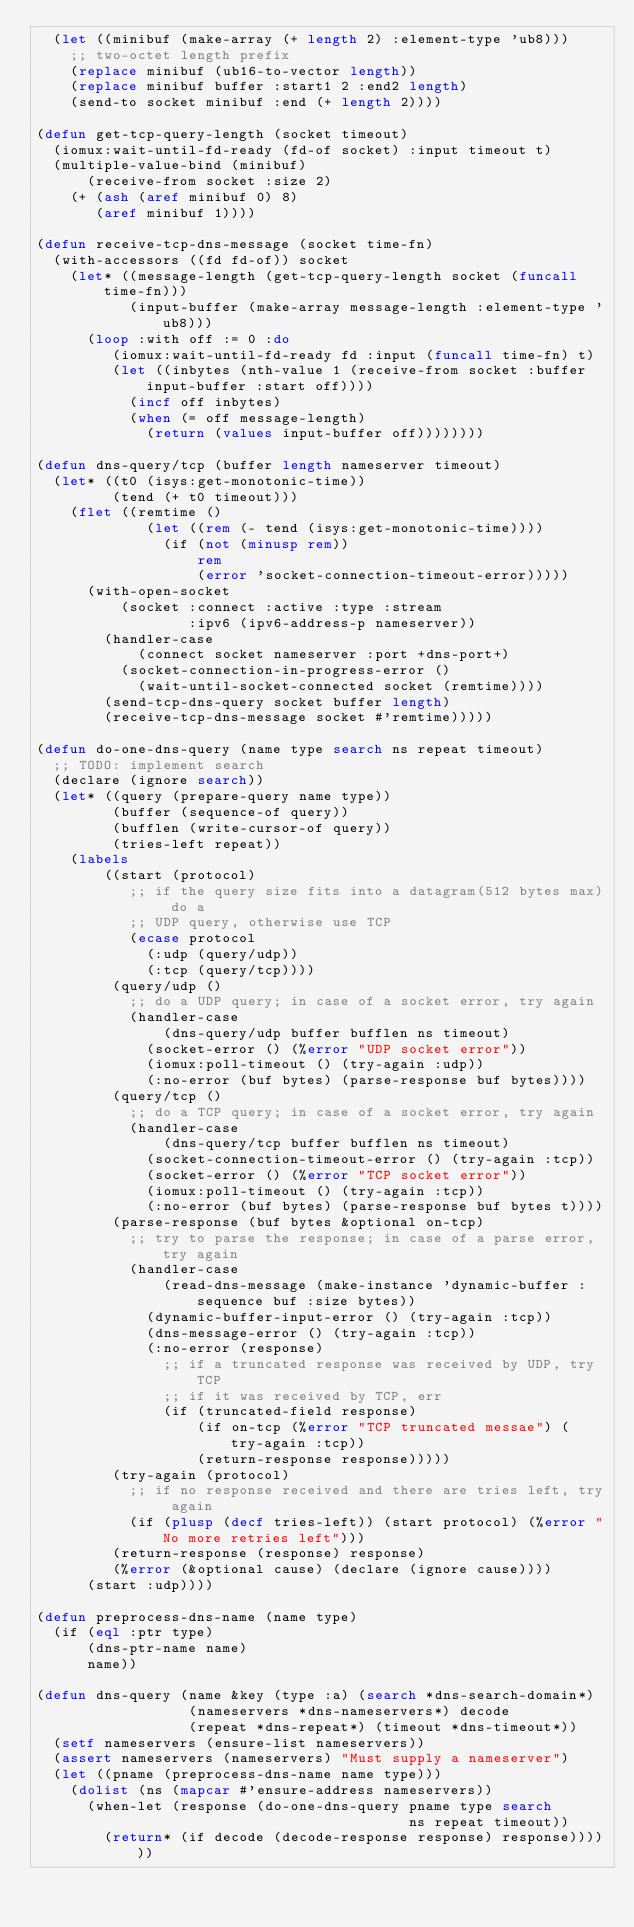<code> <loc_0><loc_0><loc_500><loc_500><_Lisp_>  (let ((minibuf (make-array (+ length 2) :element-type 'ub8)))
    ;; two-octet length prefix
    (replace minibuf (ub16-to-vector length))
    (replace minibuf buffer :start1 2 :end2 length)
    (send-to socket minibuf :end (+ length 2))))

(defun get-tcp-query-length (socket timeout)
  (iomux:wait-until-fd-ready (fd-of socket) :input timeout t)
  (multiple-value-bind (minibuf)
      (receive-from socket :size 2)
    (+ (ash (aref minibuf 0) 8)
       (aref minibuf 1))))

(defun receive-tcp-dns-message (socket time-fn)
  (with-accessors ((fd fd-of)) socket
    (let* ((message-length (get-tcp-query-length socket (funcall time-fn)))
           (input-buffer (make-array message-length :element-type 'ub8)))
      (loop :with off := 0 :do
         (iomux:wait-until-fd-ready fd :input (funcall time-fn) t)
         (let ((inbytes (nth-value 1 (receive-from socket :buffer input-buffer :start off))))
           (incf off inbytes)
           (when (= off message-length)
             (return (values input-buffer off))))))))

(defun dns-query/tcp (buffer length nameserver timeout)
  (let* ((t0 (isys:get-monotonic-time))
         (tend (+ t0 timeout)))
    (flet ((remtime ()
             (let ((rem (- tend (isys:get-monotonic-time))))
               (if (not (minusp rem))
                   rem
                   (error 'socket-connection-timeout-error)))))
      (with-open-socket
          (socket :connect :active :type :stream
                  :ipv6 (ipv6-address-p nameserver))
        (handler-case
            (connect socket nameserver :port +dns-port+)
          (socket-connection-in-progress-error ()
            (wait-until-socket-connected socket (remtime))))
        (send-tcp-dns-query socket buffer length)
        (receive-tcp-dns-message socket #'remtime)))))

(defun do-one-dns-query (name type search ns repeat timeout)
  ;; TODO: implement search
  (declare (ignore search))
  (let* ((query (prepare-query name type))
         (buffer (sequence-of query))
         (bufflen (write-cursor-of query))
         (tries-left repeat))
    (labels
        ((start (protocol)
           ;; if the query size fits into a datagram(512 bytes max) do a
           ;; UDP query, otherwise use TCP
           (ecase protocol
             (:udp (query/udp))
             (:tcp (query/tcp))))
         (query/udp ()
           ;; do a UDP query; in case of a socket error, try again
           (handler-case
               (dns-query/udp buffer bufflen ns timeout)
             (socket-error () (%error "UDP socket error"))
             (iomux:poll-timeout () (try-again :udp))
             (:no-error (buf bytes) (parse-response buf bytes))))
         (query/tcp ()
           ;; do a TCP query; in case of a socket error, try again
           (handler-case
               (dns-query/tcp buffer bufflen ns timeout)
             (socket-connection-timeout-error () (try-again :tcp))
             (socket-error () (%error "TCP socket error"))
             (iomux:poll-timeout () (try-again :tcp))
             (:no-error (buf bytes) (parse-response buf bytes t))))
         (parse-response (buf bytes &optional on-tcp)
           ;; try to parse the response; in case of a parse error, try again
           (handler-case
               (read-dns-message (make-instance 'dynamic-buffer :sequence buf :size bytes))
             (dynamic-buffer-input-error () (try-again :tcp))
             (dns-message-error () (try-again :tcp))
             (:no-error (response)
               ;; if a truncated response was received by UDP, try TCP
               ;; if it was received by TCP, err
               (if (truncated-field response)
                   (if on-tcp (%error "TCP truncated messae") (try-again :tcp))
                   (return-response response)))))
         (try-again (protocol)
           ;; if no response received and there are tries left, try again
           (if (plusp (decf tries-left)) (start protocol) (%error "No more retries left")))
         (return-response (response) response)
         (%error (&optional cause) (declare (ignore cause))))
      (start :udp))))

(defun preprocess-dns-name (name type)
  (if (eql :ptr type)
      (dns-ptr-name name)
      name))

(defun dns-query (name &key (type :a) (search *dns-search-domain*)
                  (nameservers *dns-nameservers*) decode
                  (repeat *dns-repeat*) (timeout *dns-timeout*))
  (setf nameservers (ensure-list nameservers))
  (assert nameservers (nameservers) "Must supply a nameserver")
  (let ((pname (preprocess-dns-name name type)))
    (dolist (ns (mapcar #'ensure-address nameservers))
      (when-let (response (do-one-dns-query pname type search
                                            ns repeat timeout))
        (return* (if decode (decode-response response) response))))))
</code> 